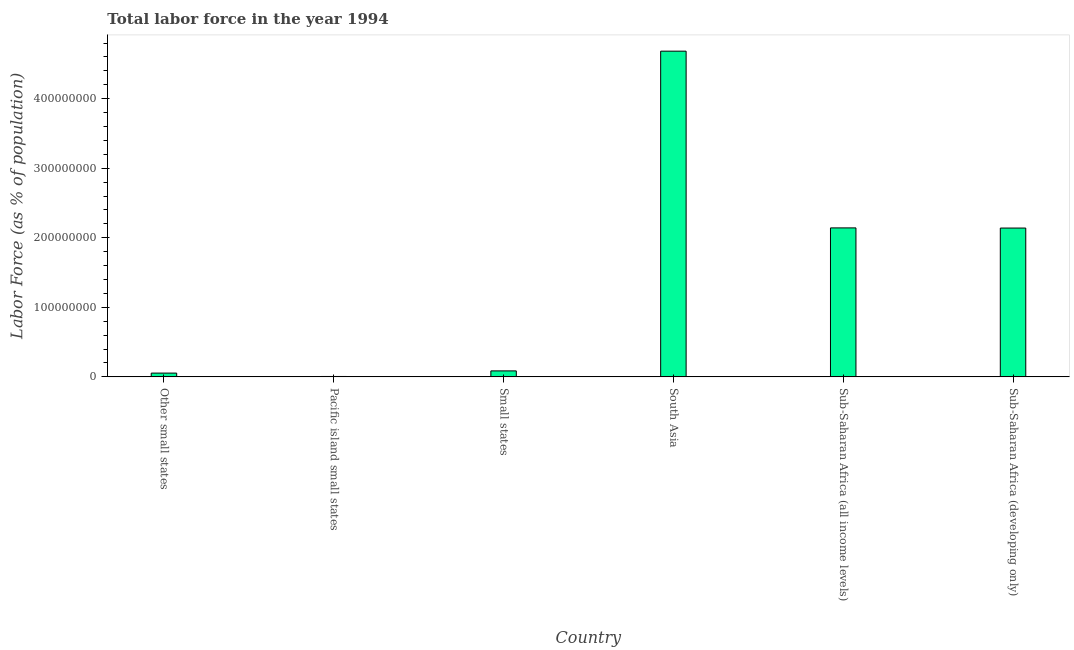Does the graph contain any zero values?
Your answer should be compact. No. What is the title of the graph?
Give a very brief answer. Total labor force in the year 1994. What is the label or title of the X-axis?
Give a very brief answer. Country. What is the label or title of the Y-axis?
Make the answer very short. Labor Force (as % of population). What is the total labor force in Sub-Saharan Africa (all income levels)?
Your response must be concise. 2.14e+08. Across all countries, what is the maximum total labor force?
Offer a terse response. 4.68e+08. Across all countries, what is the minimum total labor force?
Offer a very short reply. 5.78e+05. In which country was the total labor force minimum?
Make the answer very short. Pacific island small states. What is the sum of the total labor force?
Offer a very short reply. 9.11e+08. What is the difference between the total labor force in Other small states and South Asia?
Make the answer very short. -4.63e+08. What is the average total labor force per country?
Provide a short and direct response. 1.52e+08. What is the median total labor force?
Your response must be concise. 1.11e+08. What is the ratio of the total labor force in Pacific island small states to that in South Asia?
Ensure brevity in your answer.  0. Is the difference between the total labor force in Small states and Sub-Saharan Africa (all income levels) greater than the difference between any two countries?
Your answer should be compact. No. What is the difference between the highest and the second highest total labor force?
Offer a terse response. 2.54e+08. What is the difference between the highest and the lowest total labor force?
Provide a succinct answer. 4.68e+08. How many bars are there?
Your answer should be very brief. 6. Are all the bars in the graph horizontal?
Offer a very short reply. No. What is the difference between two consecutive major ticks on the Y-axis?
Your answer should be very brief. 1.00e+08. What is the Labor Force (as % of population) of Other small states?
Provide a succinct answer. 5.42e+06. What is the Labor Force (as % of population) in Pacific island small states?
Provide a succinct answer. 5.78e+05. What is the Labor Force (as % of population) in Small states?
Provide a short and direct response. 8.59e+06. What is the Labor Force (as % of population) of South Asia?
Offer a terse response. 4.68e+08. What is the Labor Force (as % of population) of Sub-Saharan Africa (all income levels)?
Give a very brief answer. 2.14e+08. What is the Labor Force (as % of population) of Sub-Saharan Africa (developing only)?
Give a very brief answer. 2.14e+08. What is the difference between the Labor Force (as % of population) in Other small states and Pacific island small states?
Provide a succinct answer. 4.84e+06. What is the difference between the Labor Force (as % of population) in Other small states and Small states?
Make the answer very short. -3.17e+06. What is the difference between the Labor Force (as % of population) in Other small states and South Asia?
Provide a short and direct response. -4.63e+08. What is the difference between the Labor Force (as % of population) in Other small states and Sub-Saharan Africa (all income levels)?
Ensure brevity in your answer.  -2.09e+08. What is the difference between the Labor Force (as % of population) in Other small states and Sub-Saharan Africa (developing only)?
Your answer should be very brief. -2.09e+08. What is the difference between the Labor Force (as % of population) in Pacific island small states and Small states?
Your answer should be very brief. -8.02e+06. What is the difference between the Labor Force (as % of population) in Pacific island small states and South Asia?
Your answer should be very brief. -4.68e+08. What is the difference between the Labor Force (as % of population) in Pacific island small states and Sub-Saharan Africa (all income levels)?
Your answer should be very brief. -2.14e+08. What is the difference between the Labor Force (as % of population) in Pacific island small states and Sub-Saharan Africa (developing only)?
Offer a very short reply. -2.13e+08. What is the difference between the Labor Force (as % of population) in Small states and South Asia?
Offer a very short reply. -4.60e+08. What is the difference between the Labor Force (as % of population) in Small states and Sub-Saharan Africa (all income levels)?
Your answer should be very brief. -2.06e+08. What is the difference between the Labor Force (as % of population) in Small states and Sub-Saharan Africa (developing only)?
Give a very brief answer. -2.05e+08. What is the difference between the Labor Force (as % of population) in South Asia and Sub-Saharan Africa (all income levels)?
Keep it short and to the point. 2.54e+08. What is the difference between the Labor Force (as % of population) in South Asia and Sub-Saharan Africa (developing only)?
Provide a short and direct response. 2.54e+08. What is the difference between the Labor Force (as % of population) in Sub-Saharan Africa (all income levels) and Sub-Saharan Africa (developing only)?
Your answer should be compact. 2.21e+05. What is the ratio of the Labor Force (as % of population) in Other small states to that in Pacific island small states?
Give a very brief answer. 9.38. What is the ratio of the Labor Force (as % of population) in Other small states to that in Small states?
Offer a very short reply. 0.63. What is the ratio of the Labor Force (as % of population) in Other small states to that in South Asia?
Offer a very short reply. 0.01. What is the ratio of the Labor Force (as % of population) in Other small states to that in Sub-Saharan Africa (all income levels)?
Offer a terse response. 0.03. What is the ratio of the Labor Force (as % of population) in Other small states to that in Sub-Saharan Africa (developing only)?
Provide a short and direct response. 0.03. What is the ratio of the Labor Force (as % of population) in Pacific island small states to that in Small states?
Keep it short and to the point. 0.07. What is the ratio of the Labor Force (as % of population) in Pacific island small states to that in South Asia?
Offer a terse response. 0. What is the ratio of the Labor Force (as % of population) in Pacific island small states to that in Sub-Saharan Africa (all income levels)?
Give a very brief answer. 0. What is the ratio of the Labor Force (as % of population) in Pacific island small states to that in Sub-Saharan Africa (developing only)?
Keep it short and to the point. 0. What is the ratio of the Labor Force (as % of population) in Small states to that in South Asia?
Offer a very short reply. 0.02. What is the ratio of the Labor Force (as % of population) in Small states to that in Sub-Saharan Africa (developing only)?
Your response must be concise. 0.04. What is the ratio of the Labor Force (as % of population) in South Asia to that in Sub-Saharan Africa (all income levels)?
Keep it short and to the point. 2.19. What is the ratio of the Labor Force (as % of population) in South Asia to that in Sub-Saharan Africa (developing only)?
Make the answer very short. 2.19. What is the ratio of the Labor Force (as % of population) in Sub-Saharan Africa (all income levels) to that in Sub-Saharan Africa (developing only)?
Keep it short and to the point. 1. 